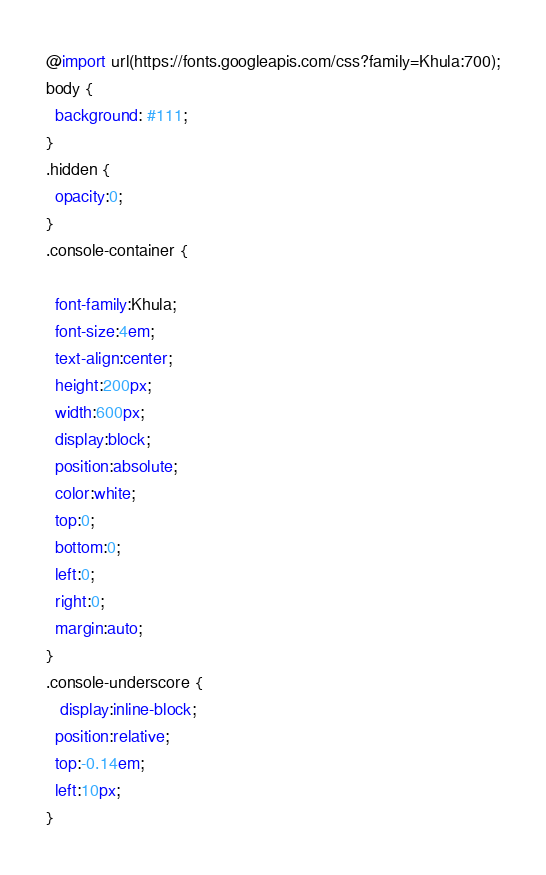Convert code to text. <code><loc_0><loc_0><loc_500><loc_500><_CSS_>@import url(https://fonts.googleapis.com/css?family=Khula:700);
body {
  background: #111;
}
.hidden {
  opacity:0;
}
.console-container {
 
  font-family:Khula;
  font-size:4em;
  text-align:center;
  height:200px;
  width:600px;
  display:block;
  position:absolute;
  color:white;
  top:0;
  bottom:0;
  left:0;
  right:0;
  margin:auto;
}
.console-underscore {
   display:inline-block;
  position:relative;
  top:-0.14em;
  left:10px;
}
</code> 